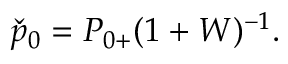<formula> <loc_0><loc_0><loc_500><loc_500>\begin{array} { r } { \check { p } _ { 0 } = { P } _ { 0 + } ( 1 + W ) ^ { - 1 } . } \end{array}</formula> 